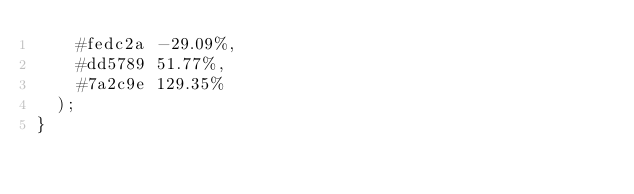<code> <loc_0><loc_0><loc_500><loc_500><_CSS_>    #fedc2a -29.09%,
    #dd5789 51.77%,
    #7a2c9e 129.35%
  );
}
</code> 